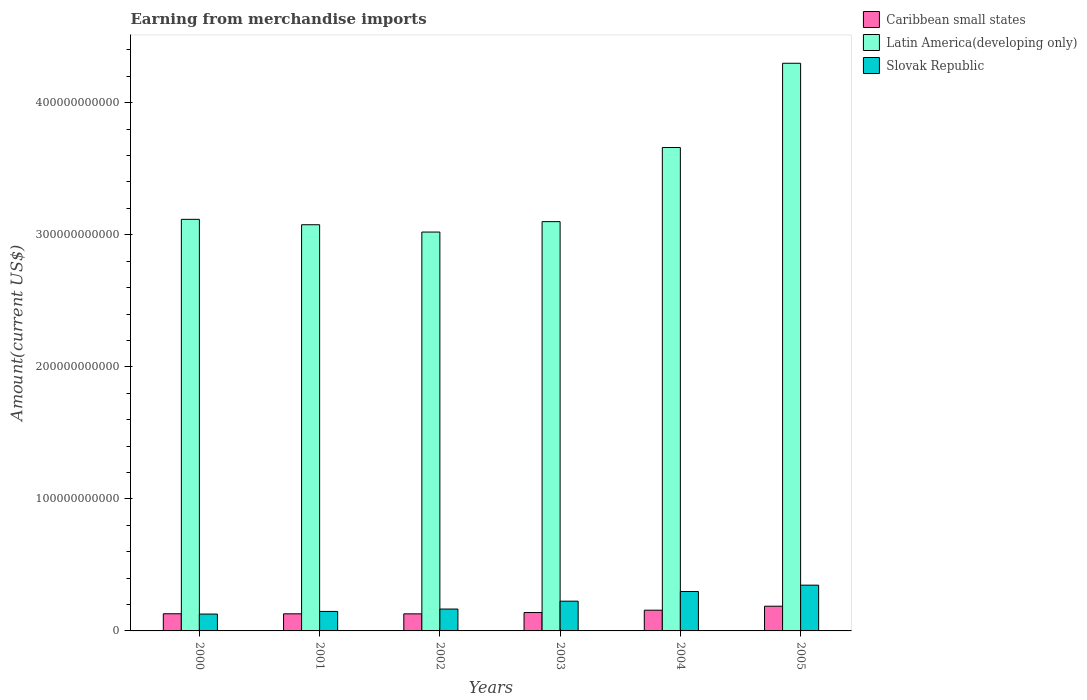How many different coloured bars are there?
Your answer should be compact. 3. How many groups of bars are there?
Provide a succinct answer. 6. Are the number of bars on each tick of the X-axis equal?
Keep it short and to the point. Yes. How many bars are there on the 1st tick from the left?
Make the answer very short. 3. How many bars are there on the 3rd tick from the right?
Give a very brief answer. 3. What is the amount earned from merchandise imports in Latin America(developing only) in 2001?
Your answer should be compact. 3.08e+11. Across all years, what is the maximum amount earned from merchandise imports in Latin America(developing only)?
Keep it short and to the point. 4.30e+11. Across all years, what is the minimum amount earned from merchandise imports in Slovak Republic?
Offer a very short reply. 1.28e+1. What is the total amount earned from merchandise imports in Latin America(developing only) in the graph?
Keep it short and to the point. 2.03e+12. What is the difference between the amount earned from merchandise imports in Caribbean small states in 2000 and that in 2003?
Provide a short and direct response. -9.32e+08. What is the difference between the amount earned from merchandise imports in Slovak Republic in 2000 and the amount earned from merchandise imports in Latin America(developing only) in 2001?
Give a very brief answer. -2.95e+11. What is the average amount earned from merchandise imports in Latin America(developing only) per year?
Your answer should be very brief. 3.38e+11. In the year 2005, what is the difference between the amount earned from merchandise imports in Caribbean small states and amount earned from merchandise imports in Slovak Republic?
Offer a terse response. -1.59e+1. In how many years, is the amount earned from merchandise imports in Slovak Republic greater than 280000000000 US$?
Offer a terse response. 0. What is the ratio of the amount earned from merchandise imports in Caribbean small states in 2000 to that in 2003?
Provide a succinct answer. 0.93. Is the amount earned from merchandise imports in Latin America(developing only) in 2001 less than that in 2002?
Provide a short and direct response. No. What is the difference between the highest and the second highest amount earned from merchandise imports in Latin America(developing only)?
Provide a succinct answer. 6.38e+1. What is the difference between the highest and the lowest amount earned from merchandise imports in Latin America(developing only)?
Provide a short and direct response. 1.28e+11. In how many years, is the amount earned from merchandise imports in Slovak Republic greater than the average amount earned from merchandise imports in Slovak Republic taken over all years?
Your response must be concise. 3. What does the 1st bar from the left in 2000 represents?
Your response must be concise. Caribbean small states. What does the 3rd bar from the right in 2003 represents?
Give a very brief answer. Caribbean small states. Is it the case that in every year, the sum of the amount earned from merchandise imports in Latin America(developing only) and amount earned from merchandise imports in Caribbean small states is greater than the amount earned from merchandise imports in Slovak Republic?
Provide a short and direct response. Yes. How many bars are there?
Ensure brevity in your answer.  18. What is the difference between two consecutive major ticks on the Y-axis?
Offer a very short reply. 1.00e+11. Does the graph contain any zero values?
Provide a succinct answer. No. Where does the legend appear in the graph?
Make the answer very short. Top right. What is the title of the graph?
Your answer should be very brief. Earning from merchandise imports. What is the label or title of the X-axis?
Provide a short and direct response. Years. What is the label or title of the Y-axis?
Offer a very short reply. Amount(current US$). What is the Amount(current US$) in Caribbean small states in 2000?
Offer a terse response. 1.30e+1. What is the Amount(current US$) in Latin America(developing only) in 2000?
Give a very brief answer. 3.12e+11. What is the Amount(current US$) of Slovak Republic in 2000?
Provide a short and direct response. 1.28e+1. What is the Amount(current US$) of Caribbean small states in 2001?
Make the answer very short. 1.29e+1. What is the Amount(current US$) in Latin America(developing only) in 2001?
Your response must be concise. 3.08e+11. What is the Amount(current US$) in Slovak Republic in 2001?
Make the answer very short. 1.48e+1. What is the Amount(current US$) in Caribbean small states in 2002?
Provide a short and direct response. 1.29e+1. What is the Amount(current US$) in Latin America(developing only) in 2002?
Keep it short and to the point. 3.02e+11. What is the Amount(current US$) of Slovak Republic in 2002?
Keep it short and to the point. 1.66e+1. What is the Amount(current US$) in Caribbean small states in 2003?
Ensure brevity in your answer.  1.39e+1. What is the Amount(current US$) in Latin America(developing only) in 2003?
Make the answer very short. 3.10e+11. What is the Amount(current US$) in Slovak Republic in 2003?
Provide a short and direct response. 2.25e+1. What is the Amount(current US$) of Caribbean small states in 2004?
Provide a succinct answer. 1.57e+1. What is the Amount(current US$) in Latin America(developing only) in 2004?
Make the answer very short. 3.66e+11. What is the Amount(current US$) of Slovak Republic in 2004?
Offer a terse response. 2.99e+1. What is the Amount(current US$) of Caribbean small states in 2005?
Provide a succinct answer. 1.87e+1. What is the Amount(current US$) in Latin America(developing only) in 2005?
Provide a short and direct response. 4.30e+11. What is the Amount(current US$) of Slovak Republic in 2005?
Give a very brief answer. 3.46e+1. Across all years, what is the maximum Amount(current US$) of Caribbean small states?
Offer a very short reply. 1.87e+1. Across all years, what is the maximum Amount(current US$) in Latin America(developing only)?
Offer a terse response. 4.30e+11. Across all years, what is the maximum Amount(current US$) in Slovak Republic?
Provide a short and direct response. 3.46e+1. Across all years, what is the minimum Amount(current US$) in Caribbean small states?
Provide a short and direct response. 1.29e+1. Across all years, what is the minimum Amount(current US$) of Latin America(developing only)?
Provide a short and direct response. 3.02e+11. Across all years, what is the minimum Amount(current US$) of Slovak Republic?
Your response must be concise. 1.28e+1. What is the total Amount(current US$) in Caribbean small states in the graph?
Keep it short and to the point. 8.72e+1. What is the total Amount(current US$) of Latin America(developing only) in the graph?
Give a very brief answer. 2.03e+12. What is the total Amount(current US$) in Slovak Republic in the graph?
Provide a short and direct response. 1.31e+11. What is the difference between the Amount(current US$) in Caribbean small states in 2000 and that in 2001?
Your answer should be compact. 4.61e+07. What is the difference between the Amount(current US$) in Latin America(developing only) in 2000 and that in 2001?
Provide a short and direct response. 4.10e+09. What is the difference between the Amount(current US$) of Slovak Republic in 2000 and that in 2001?
Your answer should be very brief. -2.00e+09. What is the difference between the Amount(current US$) of Caribbean small states in 2000 and that in 2002?
Your answer should be very brief. 7.30e+07. What is the difference between the Amount(current US$) in Latin America(developing only) in 2000 and that in 2002?
Keep it short and to the point. 9.63e+09. What is the difference between the Amount(current US$) of Slovak Republic in 2000 and that in 2002?
Offer a very short reply. -3.80e+09. What is the difference between the Amount(current US$) of Caribbean small states in 2000 and that in 2003?
Offer a terse response. -9.32e+08. What is the difference between the Amount(current US$) in Latin America(developing only) in 2000 and that in 2003?
Your answer should be compact. 1.73e+09. What is the difference between the Amount(current US$) in Slovak Republic in 2000 and that in 2003?
Keep it short and to the point. -9.76e+09. What is the difference between the Amount(current US$) in Caribbean small states in 2000 and that in 2004?
Keep it short and to the point. -2.70e+09. What is the difference between the Amount(current US$) of Latin America(developing only) in 2000 and that in 2004?
Offer a terse response. -5.44e+1. What is the difference between the Amount(current US$) in Slovak Republic in 2000 and that in 2004?
Give a very brief answer. -1.71e+1. What is the difference between the Amount(current US$) in Caribbean small states in 2000 and that in 2005?
Offer a terse response. -5.72e+09. What is the difference between the Amount(current US$) in Latin America(developing only) in 2000 and that in 2005?
Your answer should be very brief. -1.18e+11. What is the difference between the Amount(current US$) in Slovak Republic in 2000 and that in 2005?
Offer a terse response. -2.19e+1. What is the difference between the Amount(current US$) of Caribbean small states in 2001 and that in 2002?
Give a very brief answer. 2.69e+07. What is the difference between the Amount(current US$) of Latin America(developing only) in 2001 and that in 2002?
Give a very brief answer. 5.53e+09. What is the difference between the Amount(current US$) in Slovak Republic in 2001 and that in 2002?
Offer a terse response. -1.80e+09. What is the difference between the Amount(current US$) in Caribbean small states in 2001 and that in 2003?
Your answer should be compact. -9.78e+08. What is the difference between the Amount(current US$) of Latin America(developing only) in 2001 and that in 2003?
Make the answer very short. -2.36e+09. What is the difference between the Amount(current US$) in Slovak Republic in 2001 and that in 2003?
Provide a succinct answer. -7.76e+09. What is the difference between the Amount(current US$) in Caribbean small states in 2001 and that in 2004?
Your answer should be very brief. -2.74e+09. What is the difference between the Amount(current US$) of Latin America(developing only) in 2001 and that in 2004?
Your answer should be compact. -5.85e+1. What is the difference between the Amount(current US$) in Slovak Republic in 2001 and that in 2004?
Offer a terse response. -1.51e+1. What is the difference between the Amount(current US$) of Caribbean small states in 2001 and that in 2005?
Ensure brevity in your answer.  -5.77e+09. What is the difference between the Amount(current US$) of Latin America(developing only) in 2001 and that in 2005?
Make the answer very short. -1.22e+11. What is the difference between the Amount(current US$) of Slovak Republic in 2001 and that in 2005?
Your answer should be compact. -1.99e+1. What is the difference between the Amount(current US$) of Caribbean small states in 2002 and that in 2003?
Make the answer very short. -1.01e+09. What is the difference between the Amount(current US$) of Latin America(developing only) in 2002 and that in 2003?
Keep it short and to the point. -7.89e+09. What is the difference between the Amount(current US$) of Slovak Republic in 2002 and that in 2003?
Offer a terse response. -5.96e+09. What is the difference between the Amount(current US$) in Caribbean small states in 2002 and that in 2004?
Provide a succinct answer. -2.77e+09. What is the difference between the Amount(current US$) of Latin America(developing only) in 2002 and that in 2004?
Your answer should be compact. -6.40e+1. What is the difference between the Amount(current US$) of Slovak Republic in 2002 and that in 2004?
Your answer should be very brief. -1.33e+1. What is the difference between the Amount(current US$) in Caribbean small states in 2002 and that in 2005?
Make the answer very short. -5.79e+09. What is the difference between the Amount(current US$) in Latin America(developing only) in 2002 and that in 2005?
Offer a terse response. -1.28e+11. What is the difference between the Amount(current US$) of Slovak Republic in 2002 and that in 2005?
Your response must be concise. -1.81e+1. What is the difference between the Amount(current US$) of Caribbean small states in 2003 and that in 2004?
Ensure brevity in your answer.  -1.76e+09. What is the difference between the Amount(current US$) in Latin America(developing only) in 2003 and that in 2004?
Your answer should be compact. -5.61e+1. What is the difference between the Amount(current US$) in Slovak Republic in 2003 and that in 2004?
Your response must be concise. -7.34e+09. What is the difference between the Amount(current US$) of Caribbean small states in 2003 and that in 2005?
Make the answer very short. -4.79e+09. What is the difference between the Amount(current US$) of Latin America(developing only) in 2003 and that in 2005?
Ensure brevity in your answer.  -1.20e+11. What is the difference between the Amount(current US$) of Slovak Republic in 2003 and that in 2005?
Provide a short and direct response. -1.21e+1. What is the difference between the Amount(current US$) in Caribbean small states in 2004 and that in 2005?
Offer a terse response. -3.03e+09. What is the difference between the Amount(current US$) in Latin America(developing only) in 2004 and that in 2005?
Offer a very short reply. -6.38e+1. What is the difference between the Amount(current US$) of Slovak Republic in 2004 and that in 2005?
Ensure brevity in your answer.  -4.79e+09. What is the difference between the Amount(current US$) of Caribbean small states in 2000 and the Amount(current US$) of Latin America(developing only) in 2001?
Your answer should be very brief. -2.95e+11. What is the difference between the Amount(current US$) in Caribbean small states in 2000 and the Amount(current US$) in Slovak Republic in 2001?
Ensure brevity in your answer.  -1.77e+09. What is the difference between the Amount(current US$) of Latin America(developing only) in 2000 and the Amount(current US$) of Slovak Republic in 2001?
Provide a succinct answer. 2.97e+11. What is the difference between the Amount(current US$) of Caribbean small states in 2000 and the Amount(current US$) of Latin America(developing only) in 2002?
Give a very brief answer. -2.89e+11. What is the difference between the Amount(current US$) of Caribbean small states in 2000 and the Amount(current US$) of Slovak Republic in 2002?
Provide a short and direct response. -3.57e+09. What is the difference between the Amount(current US$) in Latin America(developing only) in 2000 and the Amount(current US$) in Slovak Republic in 2002?
Your response must be concise. 2.95e+11. What is the difference between the Amount(current US$) in Caribbean small states in 2000 and the Amount(current US$) in Latin America(developing only) in 2003?
Ensure brevity in your answer.  -2.97e+11. What is the difference between the Amount(current US$) in Caribbean small states in 2000 and the Amount(current US$) in Slovak Republic in 2003?
Make the answer very short. -9.53e+09. What is the difference between the Amount(current US$) in Latin America(developing only) in 2000 and the Amount(current US$) in Slovak Republic in 2003?
Provide a short and direct response. 2.89e+11. What is the difference between the Amount(current US$) of Caribbean small states in 2000 and the Amount(current US$) of Latin America(developing only) in 2004?
Keep it short and to the point. -3.53e+11. What is the difference between the Amount(current US$) in Caribbean small states in 2000 and the Amount(current US$) in Slovak Republic in 2004?
Provide a succinct answer. -1.69e+1. What is the difference between the Amount(current US$) of Latin America(developing only) in 2000 and the Amount(current US$) of Slovak Republic in 2004?
Your answer should be very brief. 2.82e+11. What is the difference between the Amount(current US$) of Caribbean small states in 2000 and the Amount(current US$) of Latin America(developing only) in 2005?
Your answer should be compact. -4.17e+11. What is the difference between the Amount(current US$) in Caribbean small states in 2000 and the Amount(current US$) in Slovak Republic in 2005?
Ensure brevity in your answer.  -2.17e+1. What is the difference between the Amount(current US$) of Latin America(developing only) in 2000 and the Amount(current US$) of Slovak Republic in 2005?
Your response must be concise. 2.77e+11. What is the difference between the Amount(current US$) in Caribbean small states in 2001 and the Amount(current US$) in Latin America(developing only) in 2002?
Provide a short and direct response. -2.89e+11. What is the difference between the Amount(current US$) in Caribbean small states in 2001 and the Amount(current US$) in Slovak Republic in 2002?
Offer a terse response. -3.61e+09. What is the difference between the Amount(current US$) of Latin America(developing only) in 2001 and the Amount(current US$) of Slovak Republic in 2002?
Keep it short and to the point. 2.91e+11. What is the difference between the Amount(current US$) of Caribbean small states in 2001 and the Amount(current US$) of Latin America(developing only) in 2003?
Provide a succinct answer. -2.97e+11. What is the difference between the Amount(current US$) of Caribbean small states in 2001 and the Amount(current US$) of Slovak Republic in 2003?
Give a very brief answer. -9.57e+09. What is the difference between the Amount(current US$) of Latin America(developing only) in 2001 and the Amount(current US$) of Slovak Republic in 2003?
Your answer should be compact. 2.85e+11. What is the difference between the Amount(current US$) in Caribbean small states in 2001 and the Amount(current US$) in Latin America(developing only) in 2004?
Provide a short and direct response. -3.53e+11. What is the difference between the Amount(current US$) in Caribbean small states in 2001 and the Amount(current US$) in Slovak Republic in 2004?
Make the answer very short. -1.69e+1. What is the difference between the Amount(current US$) in Latin America(developing only) in 2001 and the Amount(current US$) in Slovak Republic in 2004?
Ensure brevity in your answer.  2.78e+11. What is the difference between the Amount(current US$) in Caribbean small states in 2001 and the Amount(current US$) in Latin America(developing only) in 2005?
Ensure brevity in your answer.  -4.17e+11. What is the difference between the Amount(current US$) of Caribbean small states in 2001 and the Amount(current US$) of Slovak Republic in 2005?
Offer a terse response. -2.17e+1. What is the difference between the Amount(current US$) in Latin America(developing only) in 2001 and the Amount(current US$) in Slovak Republic in 2005?
Your response must be concise. 2.73e+11. What is the difference between the Amount(current US$) in Caribbean small states in 2002 and the Amount(current US$) in Latin America(developing only) in 2003?
Ensure brevity in your answer.  -2.97e+11. What is the difference between the Amount(current US$) of Caribbean small states in 2002 and the Amount(current US$) of Slovak Republic in 2003?
Provide a succinct answer. -9.60e+09. What is the difference between the Amount(current US$) in Latin America(developing only) in 2002 and the Amount(current US$) in Slovak Republic in 2003?
Provide a succinct answer. 2.80e+11. What is the difference between the Amount(current US$) in Caribbean small states in 2002 and the Amount(current US$) in Latin America(developing only) in 2004?
Provide a succinct answer. -3.53e+11. What is the difference between the Amount(current US$) of Caribbean small states in 2002 and the Amount(current US$) of Slovak Republic in 2004?
Offer a terse response. -1.69e+1. What is the difference between the Amount(current US$) of Latin America(developing only) in 2002 and the Amount(current US$) of Slovak Republic in 2004?
Your answer should be compact. 2.72e+11. What is the difference between the Amount(current US$) of Caribbean small states in 2002 and the Amount(current US$) of Latin America(developing only) in 2005?
Offer a very short reply. -4.17e+11. What is the difference between the Amount(current US$) of Caribbean small states in 2002 and the Amount(current US$) of Slovak Republic in 2005?
Provide a short and direct response. -2.17e+1. What is the difference between the Amount(current US$) in Latin America(developing only) in 2002 and the Amount(current US$) in Slovak Republic in 2005?
Offer a very short reply. 2.67e+11. What is the difference between the Amount(current US$) in Caribbean small states in 2003 and the Amount(current US$) in Latin America(developing only) in 2004?
Offer a very short reply. -3.52e+11. What is the difference between the Amount(current US$) in Caribbean small states in 2003 and the Amount(current US$) in Slovak Republic in 2004?
Offer a very short reply. -1.59e+1. What is the difference between the Amount(current US$) of Latin America(developing only) in 2003 and the Amount(current US$) of Slovak Republic in 2004?
Provide a short and direct response. 2.80e+11. What is the difference between the Amount(current US$) of Caribbean small states in 2003 and the Amount(current US$) of Latin America(developing only) in 2005?
Offer a very short reply. -4.16e+11. What is the difference between the Amount(current US$) of Caribbean small states in 2003 and the Amount(current US$) of Slovak Republic in 2005?
Offer a very short reply. -2.07e+1. What is the difference between the Amount(current US$) of Latin America(developing only) in 2003 and the Amount(current US$) of Slovak Republic in 2005?
Offer a very short reply. 2.75e+11. What is the difference between the Amount(current US$) of Caribbean small states in 2004 and the Amount(current US$) of Latin America(developing only) in 2005?
Keep it short and to the point. -4.14e+11. What is the difference between the Amount(current US$) in Caribbean small states in 2004 and the Amount(current US$) in Slovak Republic in 2005?
Offer a very short reply. -1.90e+1. What is the difference between the Amount(current US$) of Latin America(developing only) in 2004 and the Amount(current US$) of Slovak Republic in 2005?
Your answer should be compact. 3.31e+11. What is the average Amount(current US$) in Caribbean small states per year?
Make the answer very short. 1.45e+1. What is the average Amount(current US$) in Latin America(developing only) per year?
Offer a very short reply. 3.38e+11. What is the average Amount(current US$) of Slovak Republic per year?
Provide a succinct answer. 2.19e+1. In the year 2000, what is the difference between the Amount(current US$) in Caribbean small states and Amount(current US$) in Latin America(developing only)?
Give a very brief answer. -2.99e+11. In the year 2000, what is the difference between the Amount(current US$) in Caribbean small states and Amount(current US$) in Slovak Republic?
Ensure brevity in your answer.  2.35e+08. In the year 2000, what is the difference between the Amount(current US$) of Latin America(developing only) and Amount(current US$) of Slovak Republic?
Your answer should be very brief. 2.99e+11. In the year 2001, what is the difference between the Amount(current US$) of Caribbean small states and Amount(current US$) of Latin America(developing only)?
Provide a succinct answer. -2.95e+11. In the year 2001, what is the difference between the Amount(current US$) of Caribbean small states and Amount(current US$) of Slovak Republic?
Provide a short and direct response. -1.81e+09. In the year 2001, what is the difference between the Amount(current US$) in Latin America(developing only) and Amount(current US$) in Slovak Republic?
Your answer should be very brief. 2.93e+11. In the year 2002, what is the difference between the Amount(current US$) of Caribbean small states and Amount(current US$) of Latin America(developing only)?
Provide a succinct answer. -2.89e+11. In the year 2002, what is the difference between the Amount(current US$) of Caribbean small states and Amount(current US$) of Slovak Republic?
Offer a terse response. -3.64e+09. In the year 2002, what is the difference between the Amount(current US$) of Latin America(developing only) and Amount(current US$) of Slovak Republic?
Ensure brevity in your answer.  2.86e+11. In the year 2003, what is the difference between the Amount(current US$) of Caribbean small states and Amount(current US$) of Latin America(developing only)?
Your answer should be very brief. -2.96e+11. In the year 2003, what is the difference between the Amount(current US$) of Caribbean small states and Amount(current US$) of Slovak Republic?
Give a very brief answer. -8.60e+09. In the year 2003, what is the difference between the Amount(current US$) of Latin America(developing only) and Amount(current US$) of Slovak Republic?
Ensure brevity in your answer.  2.87e+11. In the year 2004, what is the difference between the Amount(current US$) in Caribbean small states and Amount(current US$) in Latin America(developing only)?
Offer a very short reply. -3.50e+11. In the year 2004, what is the difference between the Amount(current US$) of Caribbean small states and Amount(current US$) of Slovak Republic?
Give a very brief answer. -1.42e+1. In the year 2004, what is the difference between the Amount(current US$) of Latin America(developing only) and Amount(current US$) of Slovak Republic?
Provide a short and direct response. 3.36e+11. In the year 2005, what is the difference between the Amount(current US$) in Caribbean small states and Amount(current US$) in Latin America(developing only)?
Offer a very short reply. -4.11e+11. In the year 2005, what is the difference between the Amount(current US$) of Caribbean small states and Amount(current US$) of Slovak Republic?
Keep it short and to the point. -1.59e+1. In the year 2005, what is the difference between the Amount(current US$) in Latin America(developing only) and Amount(current US$) in Slovak Republic?
Give a very brief answer. 3.95e+11. What is the ratio of the Amount(current US$) of Caribbean small states in 2000 to that in 2001?
Your answer should be compact. 1. What is the ratio of the Amount(current US$) of Latin America(developing only) in 2000 to that in 2001?
Offer a very short reply. 1.01. What is the ratio of the Amount(current US$) in Slovak Republic in 2000 to that in 2001?
Your answer should be very brief. 0.86. What is the ratio of the Amount(current US$) in Caribbean small states in 2000 to that in 2002?
Your answer should be compact. 1.01. What is the ratio of the Amount(current US$) of Latin America(developing only) in 2000 to that in 2002?
Make the answer very short. 1.03. What is the ratio of the Amount(current US$) in Slovak Republic in 2000 to that in 2002?
Your answer should be very brief. 0.77. What is the ratio of the Amount(current US$) in Caribbean small states in 2000 to that in 2003?
Provide a short and direct response. 0.93. What is the ratio of the Amount(current US$) of Latin America(developing only) in 2000 to that in 2003?
Provide a short and direct response. 1.01. What is the ratio of the Amount(current US$) of Slovak Republic in 2000 to that in 2003?
Your answer should be compact. 0.57. What is the ratio of the Amount(current US$) in Caribbean small states in 2000 to that in 2004?
Make the answer very short. 0.83. What is the ratio of the Amount(current US$) in Latin America(developing only) in 2000 to that in 2004?
Offer a very short reply. 0.85. What is the ratio of the Amount(current US$) in Slovak Republic in 2000 to that in 2004?
Provide a succinct answer. 0.43. What is the ratio of the Amount(current US$) in Caribbean small states in 2000 to that in 2005?
Keep it short and to the point. 0.69. What is the ratio of the Amount(current US$) of Latin America(developing only) in 2000 to that in 2005?
Provide a succinct answer. 0.72. What is the ratio of the Amount(current US$) in Slovak Republic in 2000 to that in 2005?
Keep it short and to the point. 0.37. What is the ratio of the Amount(current US$) of Caribbean small states in 2001 to that in 2002?
Provide a succinct answer. 1. What is the ratio of the Amount(current US$) in Latin America(developing only) in 2001 to that in 2002?
Your answer should be compact. 1.02. What is the ratio of the Amount(current US$) in Slovak Republic in 2001 to that in 2002?
Provide a short and direct response. 0.89. What is the ratio of the Amount(current US$) of Caribbean small states in 2001 to that in 2003?
Provide a short and direct response. 0.93. What is the ratio of the Amount(current US$) in Latin America(developing only) in 2001 to that in 2003?
Your response must be concise. 0.99. What is the ratio of the Amount(current US$) of Slovak Republic in 2001 to that in 2003?
Your response must be concise. 0.66. What is the ratio of the Amount(current US$) of Caribbean small states in 2001 to that in 2004?
Provide a succinct answer. 0.83. What is the ratio of the Amount(current US$) in Latin America(developing only) in 2001 to that in 2004?
Offer a very short reply. 0.84. What is the ratio of the Amount(current US$) of Slovak Republic in 2001 to that in 2004?
Give a very brief answer. 0.49. What is the ratio of the Amount(current US$) in Caribbean small states in 2001 to that in 2005?
Provide a short and direct response. 0.69. What is the ratio of the Amount(current US$) of Latin America(developing only) in 2001 to that in 2005?
Provide a short and direct response. 0.72. What is the ratio of the Amount(current US$) of Slovak Republic in 2001 to that in 2005?
Give a very brief answer. 0.43. What is the ratio of the Amount(current US$) in Caribbean small states in 2002 to that in 2003?
Your answer should be compact. 0.93. What is the ratio of the Amount(current US$) of Latin America(developing only) in 2002 to that in 2003?
Offer a very short reply. 0.97. What is the ratio of the Amount(current US$) in Slovak Republic in 2002 to that in 2003?
Provide a succinct answer. 0.74. What is the ratio of the Amount(current US$) of Caribbean small states in 2002 to that in 2004?
Ensure brevity in your answer.  0.82. What is the ratio of the Amount(current US$) in Latin America(developing only) in 2002 to that in 2004?
Give a very brief answer. 0.83. What is the ratio of the Amount(current US$) in Slovak Republic in 2002 to that in 2004?
Your answer should be compact. 0.55. What is the ratio of the Amount(current US$) of Caribbean small states in 2002 to that in 2005?
Your response must be concise. 0.69. What is the ratio of the Amount(current US$) in Latin America(developing only) in 2002 to that in 2005?
Provide a short and direct response. 0.7. What is the ratio of the Amount(current US$) in Slovak Republic in 2002 to that in 2005?
Offer a very short reply. 0.48. What is the ratio of the Amount(current US$) of Caribbean small states in 2003 to that in 2004?
Your response must be concise. 0.89. What is the ratio of the Amount(current US$) of Latin America(developing only) in 2003 to that in 2004?
Make the answer very short. 0.85. What is the ratio of the Amount(current US$) of Slovak Republic in 2003 to that in 2004?
Make the answer very short. 0.75. What is the ratio of the Amount(current US$) in Caribbean small states in 2003 to that in 2005?
Ensure brevity in your answer.  0.74. What is the ratio of the Amount(current US$) in Latin America(developing only) in 2003 to that in 2005?
Provide a short and direct response. 0.72. What is the ratio of the Amount(current US$) of Slovak Republic in 2003 to that in 2005?
Make the answer very short. 0.65. What is the ratio of the Amount(current US$) of Caribbean small states in 2004 to that in 2005?
Ensure brevity in your answer.  0.84. What is the ratio of the Amount(current US$) of Latin America(developing only) in 2004 to that in 2005?
Give a very brief answer. 0.85. What is the ratio of the Amount(current US$) of Slovak Republic in 2004 to that in 2005?
Your response must be concise. 0.86. What is the difference between the highest and the second highest Amount(current US$) of Caribbean small states?
Give a very brief answer. 3.03e+09. What is the difference between the highest and the second highest Amount(current US$) of Latin America(developing only)?
Make the answer very short. 6.38e+1. What is the difference between the highest and the second highest Amount(current US$) in Slovak Republic?
Your answer should be compact. 4.79e+09. What is the difference between the highest and the lowest Amount(current US$) of Caribbean small states?
Give a very brief answer. 5.79e+09. What is the difference between the highest and the lowest Amount(current US$) of Latin America(developing only)?
Make the answer very short. 1.28e+11. What is the difference between the highest and the lowest Amount(current US$) in Slovak Republic?
Give a very brief answer. 2.19e+1. 